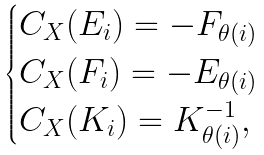Convert formula to latex. <formula><loc_0><loc_0><loc_500><loc_500>\begin{cases} C _ { X } ( E _ { i } ) = - F _ { \theta ( i ) } \\ C _ { X } ( F _ { i } ) = - E _ { \theta ( i ) } \\ C _ { X } ( K _ { i } ) = K _ { \theta ( i ) } ^ { - 1 } , \end{cases}</formula> 